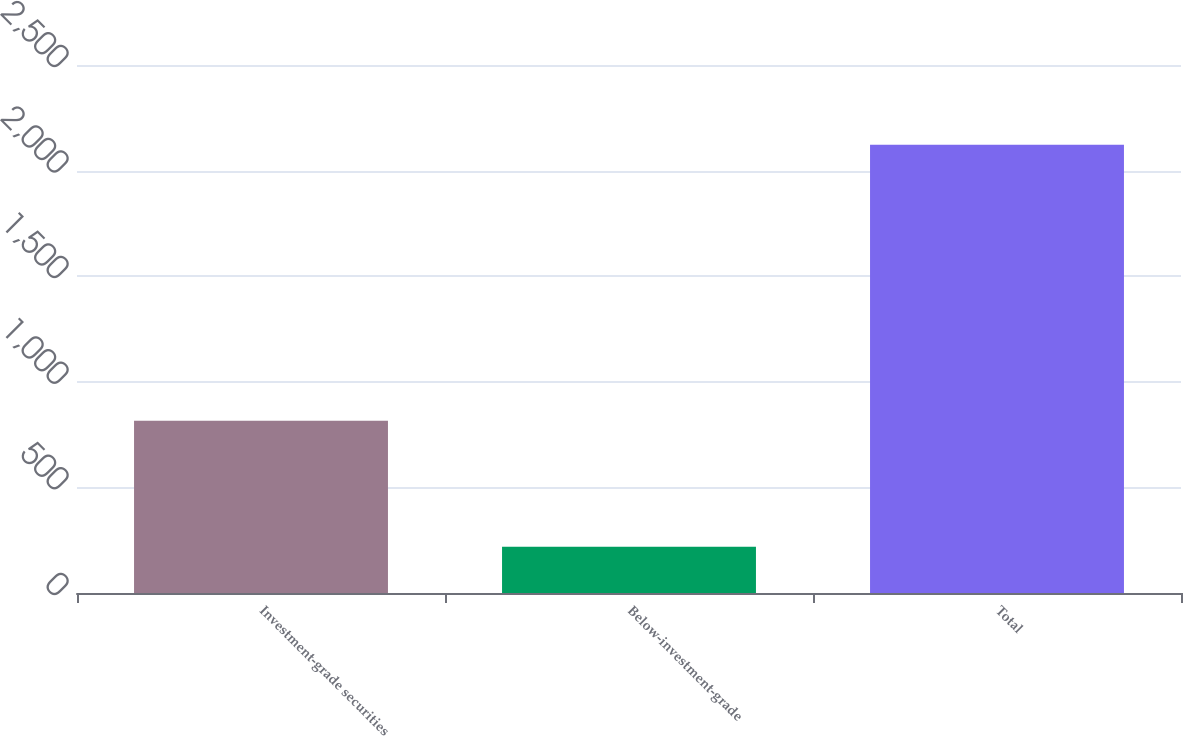<chart> <loc_0><loc_0><loc_500><loc_500><bar_chart><fcel>Investment-grade securities<fcel>Below-investment-grade<fcel>Total<nl><fcel>816<fcel>219<fcel>2122<nl></chart> 